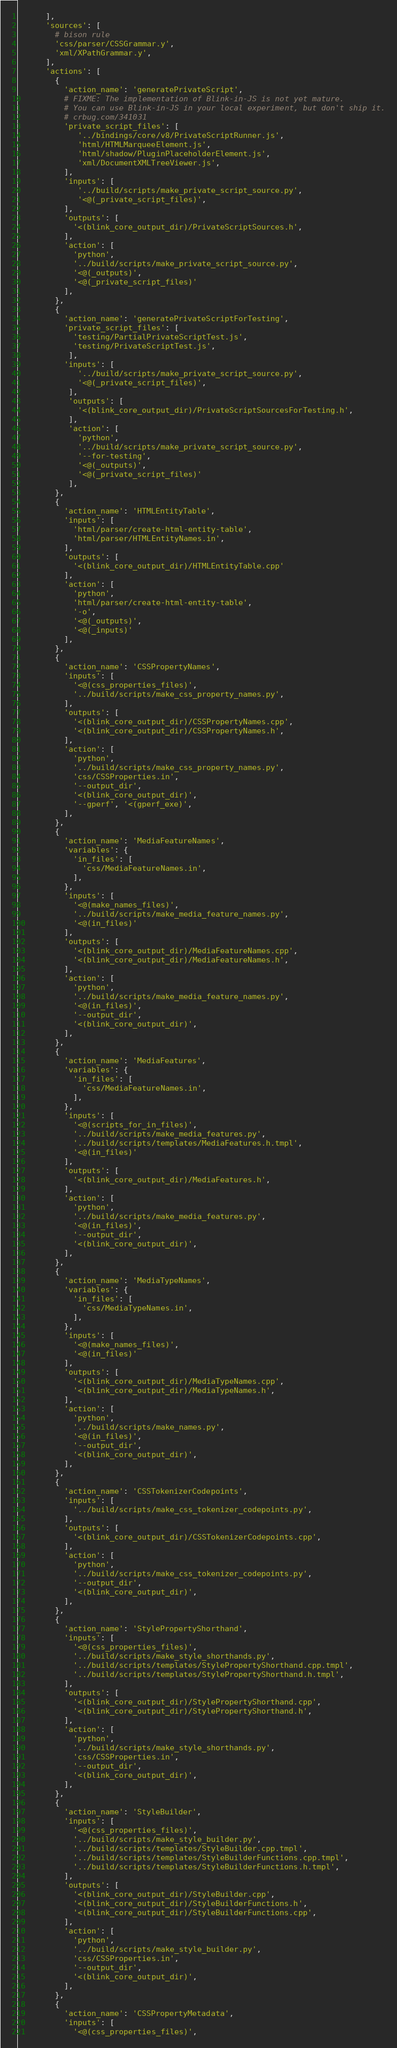<code> <loc_0><loc_0><loc_500><loc_500><_Python_>      ],
      'sources': [
        # bison rule
        'css/parser/CSSGrammar.y',
        'xml/XPathGrammar.y',
      ],
      'actions': [
        {
          'action_name': 'generatePrivateScript',
          # FIXME: The implementation of Blink-in-JS is not yet mature.
          # You can use Blink-in-JS in your local experiment, but don't ship it.
          # crbug.com/341031
          'private_script_files': [
             '../bindings/core/v8/PrivateScriptRunner.js',
             'html/HTMLMarqueeElement.js',
             'html/shadow/PluginPlaceholderElement.js',
             'xml/DocumentXMLTreeViewer.js',
          ],
          'inputs': [
             '../build/scripts/make_private_script_source.py',
             '<@(_private_script_files)',
          ],
          'outputs': [
            '<(blink_core_output_dir)/PrivateScriptSources.h',
          ],
          'action': [
            'python',
            '../build/scripts/make_private_script_source.py',
            '<@(_outputs)',
            '<@(_private_script_files)'
          ],
        },
        {
          'action_name': 'generatePrivateScriptForTesting',
          'private_script_files': [
            'testing/PartialPrivateScriptTest.js',
            'testing/PrivateScriptTest.js',
           ],
          'inputs': [
             '../build/scripts/make_private_script_source.py',
             '<@(_private_script_files)',
           ],
           'outputs': [
             '<(blink_core_output_dir)/PrivateScriptSourcesForTesting.h',
           ],
           'action': [
             'python',
             '../build/scripts/make_private_script_source.py',
             '--for-testing',
             '<@(_outputs)',
             '<@(_private_script_files)'
           ],
        },
        {
          'action_name': 'HTMLEntityTable',
          'inputs': [
            'html/parser/create-html-entity-table',
            'html/parser/HTMLEntityNames.in',
          ],
          'outputs': [
            '<(blink_core_output_dir)/HTMLEntityTable.cpp'
          ],
          'action': [
            'python',
            'html/parser/create-html-entity-table',
            '-o',
            '<@(_outputs)',
            '<@(_inputs)'
          ],
        },
        {
          'action_name': 'CSSPropertyNames',
          'inputs': [
            '<@(css_properties_files)',
            '../build/scripts/make_css_property_names.py',
          ],
          'outputs': [
            '<(blink_core_output_dir)/CSSPropertyNames.cpp',
            '<(blink_core_output_dir)/CSSPropertyNames.h',
          ],
          'action': [
            'python',
            '../build/scripts/make_css_property_names.py',
            'css/CSSProperties.in',
            '--output_dir',
            '<(blink_core_output_dir)',
            '--gperf', '<(gperf_exe)',
          ],
        },
        {
          'action_name': 'MediaFeatureNames',
          'variables': {
            'in_files': [
              'css/MediaFeatureNames.in',
            ],
          },
          'inputs': [
            '<@(make_names_files)',
            '../build/scripts/make_media_feature_names.py',
            '<@(in_files)'
          ],
          'outputs': [
            '<(blink_core_output_dir)/MediaFeatureNames.cpp',
            '<(blink_core_output_dir)/MediaFeatureNames.h',
          ],
          'action': [
            'python',
            '../build/scripts/make_media_feature_names.py',
            '<@(in_files)',
            '--output_dir',
            '<(blink_core_output_dir)',
          ],
        },
        {
          'action_name': 'MediaFeatures',
          'variables': {
            'in_files': [
              'css/MediaFeatureNames.in',
            ],
          },
          'inputs': [
            '<@(scripts_for_in_files)',
            '../build/scripts/make_media_features.py',
            '../build/scripts/templates/MediaFeatures.h.tmpl',
            '<@(in_files)'
          ],
          'outputs': [
            '<(blink_core_output_dir)/MediaFeatures.h',
          ],
          'action': [
            'python',
            '../build/scripts/make_media_features.py',
            '<@(in_files)',
            '--output_dir',
            '<(blink_core_output_dir)',
          ],
        },
        {
          'action_name': 'MediaTypeNames',
          'variables': {
            'in_files': [
              'css/MediaTypeNames.in',
            ],
          },
          'inputs': [
            '<@(make_names_files)',
            '<@(in_files)'
          ],
          'outputs': [
            '<(blink_core_output_dir)/MediaTypeNames.cpp',
            '<(blink_core_output_dir)/MediaTypeNames.h',
          ],
          'action': [
            'python',
            '../build/scripts/make_names.py',
            '<@(in_files)',
            '--output_dir',
            '<(blink_core_output_dir)',
          ],
        },
        {
          'action_name': 'CSSTokenizerCodepoints',
          'inputs': [
            '../build/scripts/make_css_tokenizer_codepoints.py',
          ],
          'outputs': [
            '<(blink_core_output_dir)/CSSTokenizerCodepoints.cpp',
          ],
          'action': [
            'python',
            '../build/scripts/make_css_tokenizer_codepoints.py',
            '--output_dir',
            '<(blink_core_output_dir)',
          ],
        },
        {
          'action_name': 'StylePropertyShorthand',
          'inputs': [
            '<@(css_properties_files)',
            '../build/scripts/make_style_shorthands.py',
            '../build/scripts/templates/StylePropertyShorthand.cpp.tmpl',
            '../build/scripts/templates/StylePropertyShorthand.h.tmpl',
          ],
          'outputs': [
            '<(blink_core_output_dir)/StylePropertyShorthand.cpp',
            '<(blink_core_output_dir)/StylePropertyShorthand.h',
          ],
          'action': [
            'python',
            '../build/scripts/make_style_shorthands.py',
            'css/CSSProperties.in',
            '--output_dir',
            '<(blink_core_output_dir)',
          ],
        },
        {
          'action_name': 'StyleBuilder',
          'inputs': [
            '<@(css_properties_files)',
            '../build/scripts/make_style_builder.py',
            '../build/scripts/templates/StyleBuilder.cpp.tmpl',
            '../build/scripts/templates/StyleBuilderFunctions.cpp.tmpl',
            '../build/scripts/templates/StyleBuilderFunctions.h.tmpl',
          ],
          'outputs': [
            '<(blink_core_output_dir)/StyleBuilder.cpp',
            '<(blink_core_output_dir)/StyleBuilderFunctions.h',
            '<(blink_core_output_dir)/StyleBuilderFunctions.cpp',
          ],
          'action': [
            'python',
            '../build/scripts/make_style_builder.py',
            'css/CSSProperties.in',
            '--output_dir',
            '<(blink_core_output_dir)',
          ],
        },
        {
          'action_name': 'CSSPropertyMetadata',
          'inputs': [
            '<@(css_properties_files)',</code> 